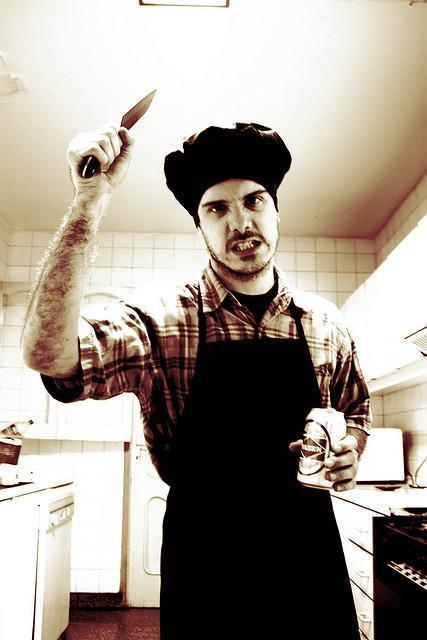How many ovens are in the photo?
Give a very brief answer. 2. 